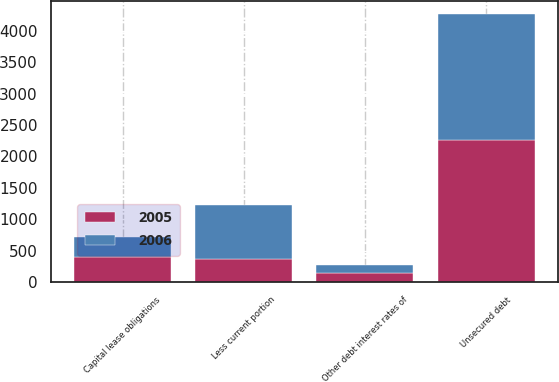<chart> <loc_0><loc_0><loc_500><loc_500><stacked_bar_chart><ecel><fcel>Unsecured debt<fcel>Capital lease obligations<fcel>Other debt interest rates of<fcel>Less current portion<nl><fcel>2006<fcel>2006<fcel>310<fcel>126<fcel>850<nl><fcel>2005<fcel>2255<fcel>401<fcel>140<fcel>369<nl></chart> 